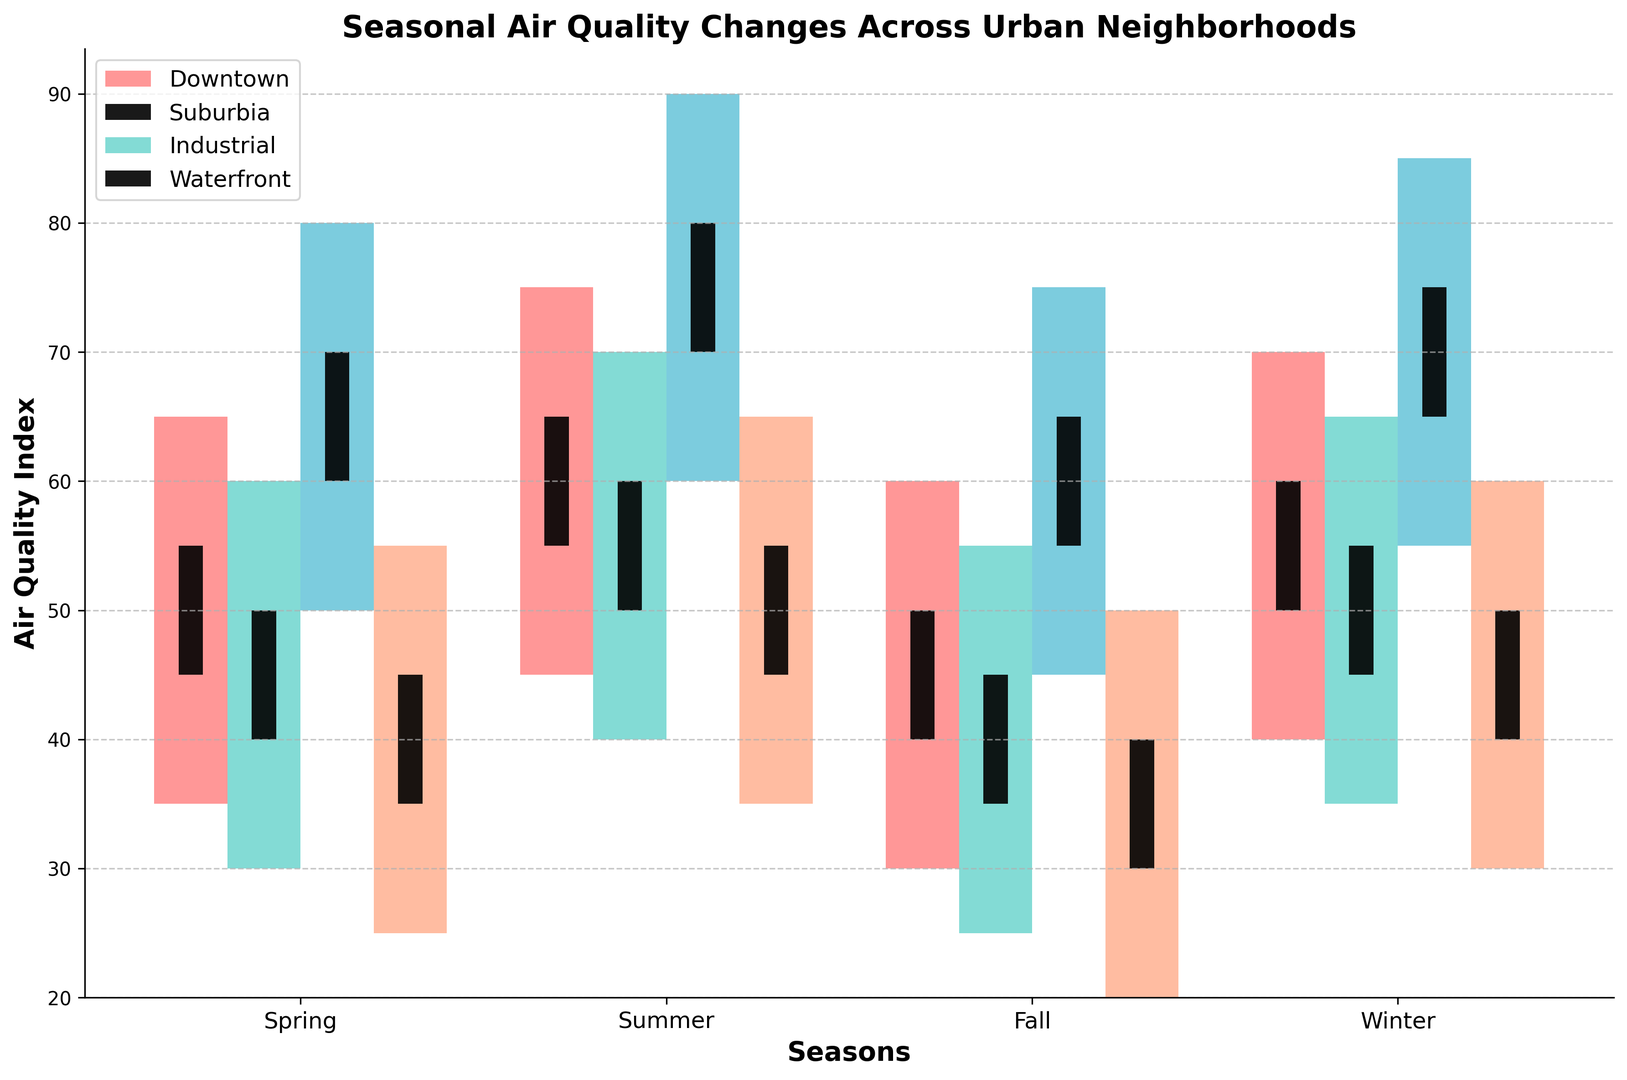Which neighborhood has the highest air quality index in Summer? To find the highest air quality index in Summer, look for the tallest bar in the Summer section. The tallest bar represents the Industrial neighborhood with a high value of 90.
Answer: Industrial What is the difference in the closing air quality index between Downtown and Suburbia in Winter? For Winter, find the closing values for both Downtown (60) and Suburbia (55). The difference is 60 - 55 = 5.
Answer: 5 Which season has the lowest air quality index across all neighborhoods? Check for the lowest bars in each season across all neighborhoods. The Waterfront neighborhood in Fall has the lowest air quality index with a low value of 20.
Answer: Fall How much does the air quality index improve from Spring to Summer in the Industrial neighborhood? In the Industrial neighborhood, the closing values are 70 in Spring and 80 in Summer, making the improvement 80 - 70 = 10.
Answer: 10 In which season does the Waterfront neighborhood see the greatest range in air quality index? Find the range by subtracting the lowest values from the highest values for each season in the Waterfront neighborhood: Spring (55-25=30), Summer (65-35=30), Fall (50-20=30), Winter (60-30=30). They all have a range of 30.
Answer: All Seasons have the same range of 30 What is the average opening air quality index for all neighborhoods in Fall? Sum the opening values for all neighborhoods in Fall (40 + 35 + 55 + 30 = 160) and divide by the number of neighborhoods (4): 160/4 = 40.
Answer: 40 Which neighborhood has the smallest change in air quality index from Summer to Winter? Compare the closing values for each neighborhood in Summer and Winter: Downtown (65-60=5), Suburbia (60-55=5), Industrial (80-75=5), Waterfront (55-50=5). All neighborhoods have the same change of 5.
Answer: All Neighborhoods have the same change of 5 Is the air quality index for any neighborhood the same for Spring and Fall? Compare closing values for each neighborhood between Spring and Fall: Downtown (55 and 50), Suburbia (50 and 45), Industrial (70 and 65), Waterfront (45 and 40). None of the neighborhoods have the same values.
Answer: No Which neighborhood has the most stable air quality index during each season, indicated by the smallest range? Calculate the range for each neighborhood across all seasons. The Downtown ranges are Spring (30), Summer (30), Fall (30), Winter (30), Suburbia (30, 30, 30, 30), Industrial (30, 30, 30, 30), Waterfront (30, 30, 30, 30). All neighborhoods have the same stability.
Answer: All Neighborhoods have the same stability Is there any season where all neighborhoods have overlapping ranges of air quality values? Compare ranges for each neighborhood within each season: Spring (Downtown [35-65], Suburbia [30-60], Industrial [50-80], Waterfront [25-55]), Summer (Downtown [45-75], Suburbia [40-70], Industrial [60-90], Waterfront [35-65]), Fall (Downtown [30-60], Suburbia [25-55], Industrial [45-75], Waterfront [20-50]), Winter (Downtown [40-70], Suburbia [35-65], Industrial [55-85], Waterfront [30-60]). No full overlap in any season.
Answer: No 